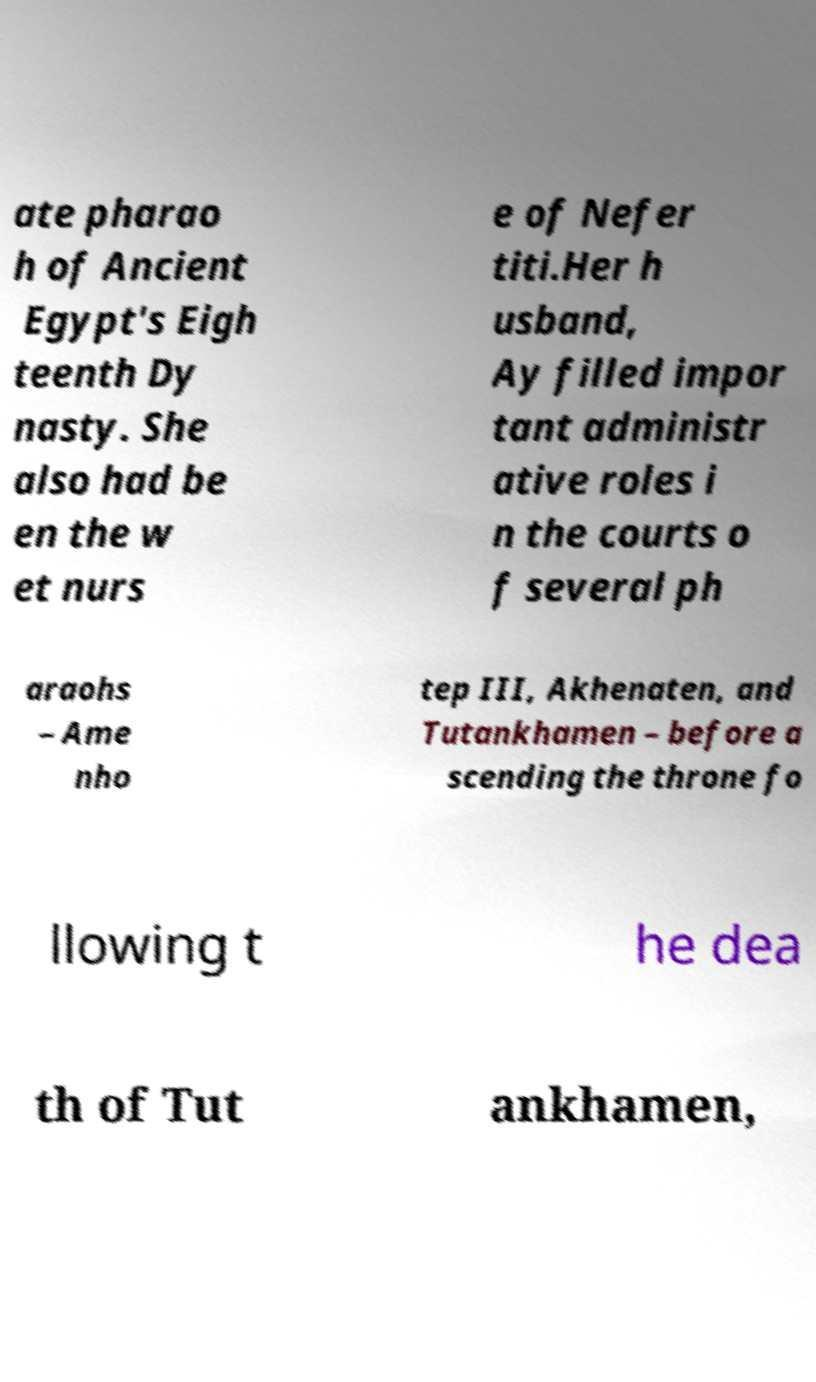For documentation purposes, I need the text within this image transcribed. Could you provide that? ate pharao h of Ancient Egypt's Eigh teenth Dy nasty. She also had be en the w et nurs e of Nefer titi.Her h usband, Ay filled impor tant administr ative roles i n the courts o f several ph araohs – Ame nho tep III, Akhenaten, and Tutankhamen – before a scending the throne fo llowing t he dea th of Tut ankhamen, 